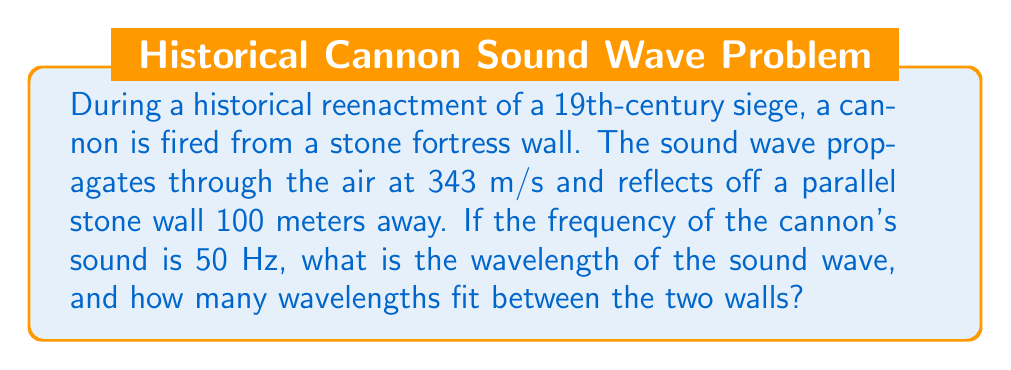Teach me how to tackle this problem. Let's approach this problem step-by-step:

1) First, we need to calculate the wavelength of the sound wave. The wavelength ($\lambda$) is related to the speed of sound ($v$) and the frequency ($f$) by the equation:

   $$v = f\lambda$$

2) Rearranging this equation to solve for $\lambda$:

   $$\lambda = \frac{v}{f}$$

3) Substituting the given values:
   $v = 343$ m/s (speed of sound in air)
   $f = 50$ Hz

   $$\lambda = \frac{343 \text{ m/s}}{50 \text{ Hz}} = 6.86 \text{ m}$$

4) Now that we have the wavelength, we can determine how many wavelengths fit between the two walls. The distance between the walls is 100 meters.

5) To find the number of wavelengths, we divide the total distance by the wavelength:

   $$\text{Number of wavelengths} = \frac{\text{Total distance}}{\text{Wavelength}} = \frac{100 \text{ m}}{6.86 \text{ m}} \approx 14.58$$

6) Since we can't have a fraction of a wavelength in this context, we round down to the nearest whole number.

Therefore, the wavelength is 6.86 meters, and 14 complete wavelengths fit between the two walls.
Answer: Wavelength: 6.86 m; Number of wavelengths: 14 